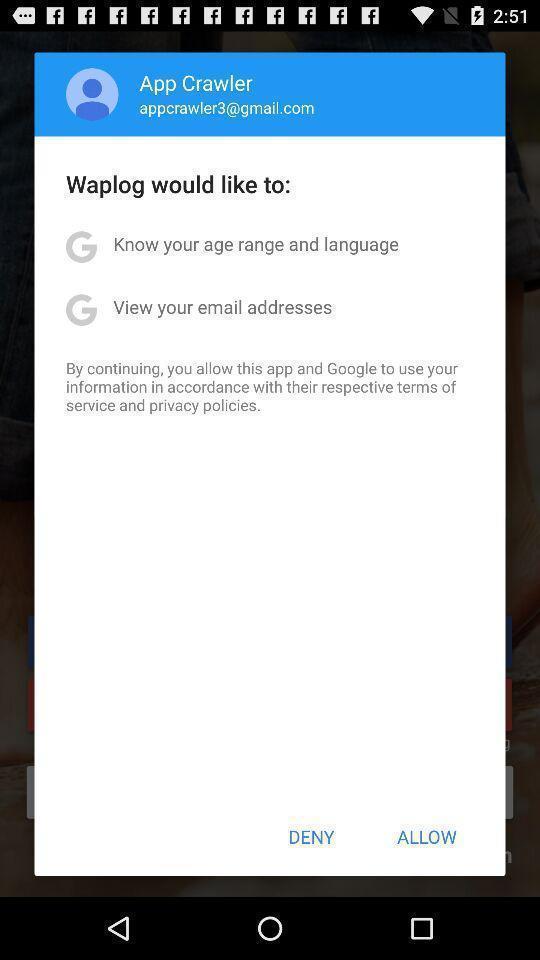Explain what's happening in this screen capture. Pop-up shows to continue with social app. 